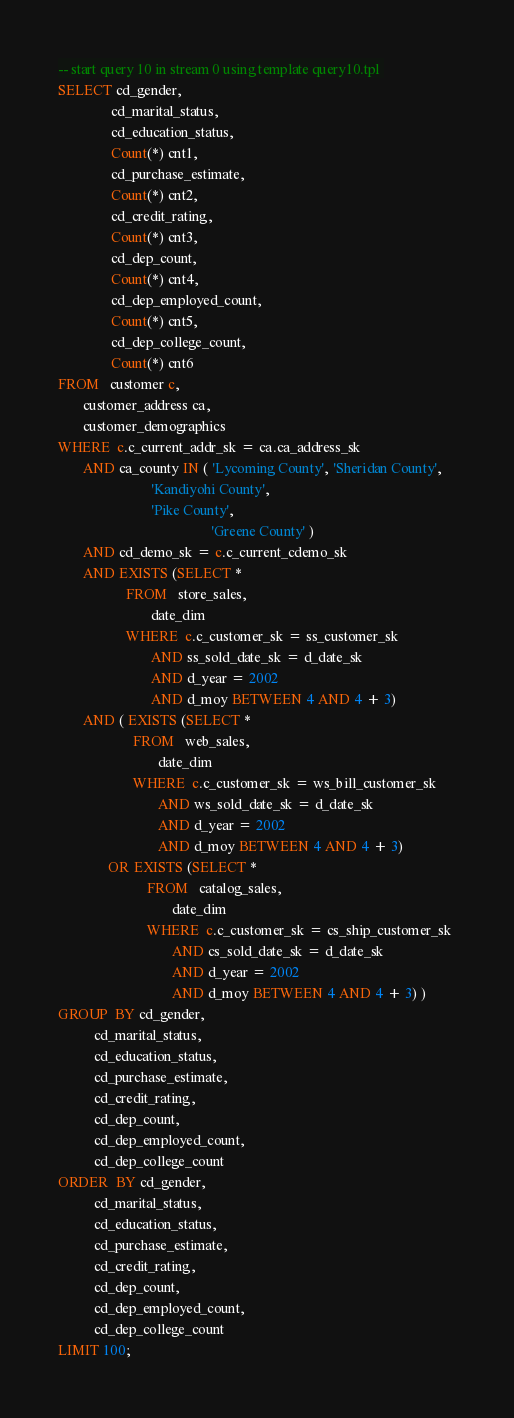Convert code to text. <code><loc_0><loc_0><loc_500><loc_500><_SQL_>-- start query 10 in stream 0 using template query10.tpl 
SELECT cd_gender, 
               cd_marital_status, 
               cd_education_status, 
               Count(*) cnt1, 
               cd_purchase_estimate, 
               Count(*) cnt2, 
               cd_credit_rating, 
               Count(*) cnt3, 
               cd_dep_count, 
               Count(*) cnt4, 
               cd_dep_employed_count, 
               Count(*) cnt5, 
               cd_dep_college_count, 
               Count(*) cnt6 
FROM   customer c, 
       customer_address ca, 
       customer_demographics 
WHERE  c.c_current_addr_sk = ca.ca_address_sk 
       AND ca_county IN ( 'Lycoming County', 'Sheridan County', 
                          'Kandiyohi County', 
                          'Pike County', 
                                           'Greene County' ) 
       AND cd_demo_sk = c.c_current_cdemo_sk 
       AND EXISTS (SELECT * 
                   FROM   store_sales, 
                          date_dim 
                   WHERE  c.c_customer_sk = ss_customer_sk 
                          AND ss_sold_date_sk = d_date_sk 
                          AND d_year = 2002 
                          AND d_moy BETWEEN 4 AND 4 + 3) 
       AND ( EXISTS (SELECT * 
                     FROM   web_sales, 
                            date_dim 
                     WHERE  c.c_customer_sk = ws_bill_customer_sk 
                            AND ws_sold_date_sk = d_date_sk 
                            AND d_year = 2002 
                            AND d_moy BETWEEN 4 AND 4 + 3) 
              OR EXISTS (SELECT * 
                         FROM   catalog_sales, 
                                date_dim 
                         WHERE  c.c_customer_sk = cs_ship_customer_sk 
                                AND cs_sold_date_sk = d_date_sk 
                                AND d_year = 2002 
                                AND d_moy BETWEEN 4 AND 4 + 3) ) 
GROUP  BY cd_gender, 
          cd_marital_status, 
          cd_education_status, 
          cd_purchase_estimate, 
          cd_credit_rating, 
          cd_dep_count, 
          cd_dep_employed_count, 
          cd_dep_college_count 
ORDER  BY cd_gender, 
          cd_marital_status, 
          cd_education_status, 
          cd_purchase_estimate, 
          cd_credit_rating, 
          cd_dep_count, 
          cd_dep_employed_count, 
          cd_dep_college_count
LIMIT 100; 
</code> 